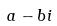Convert formula to latex. <formula><loc_0><loc_0><loc_500><loc_500>a - b i</formula> 